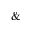<formula> <loc_0><loc_0><loc_500><loc_500>\&</formula> 